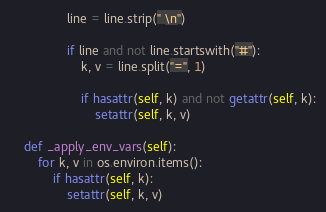Convert code to text. <code><loc_0><loc_0><loc_500><loc_500><_Python_>                line = line.strip(" \n")

                if line and not line.startswith("#"):
                    k, v = line.split("=", 1)

                    if hasattr(self, k) and not getattr(self, k):
                        setattr(self, k, v)

    def _apply_env_vars(self):
        for k, v in os.environ.items():
            if hasattr(self, k):
                setattr(self, k, v)
</code> 